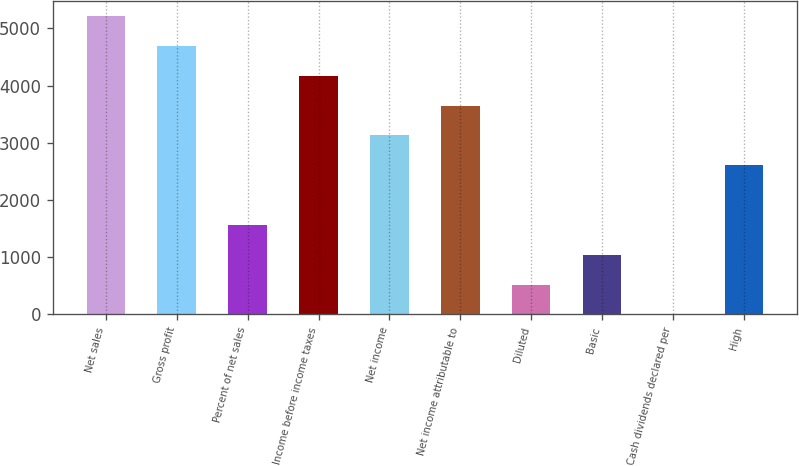Convert chart. <chart><loc_0><loc_0><loc_500><loc_500><bar_chart><fcel>Net sales<fcel>Gross profit<fcel>Percent of net sales<fcel>Income before income taxes<fcel>Net income<fcel>Net income attributable to<fcel>Diluted<fcel>Basic<fcel>Cash dividends declared per<fcel>High<nl><fcel>5211<fcel>4689.96<fcel>1563.72<fcel>4168.92<fcel>3126.84<fcel>3647.88<fcel>521.64<fcel>1042.68<fcel>0.6<fcel>2605.8<nl></chart> 